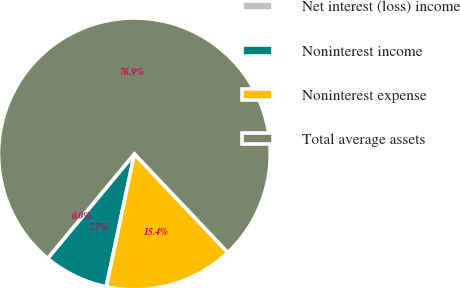Convert chart to OTSL. <chart><loc_0><loc_0><loc_500><loc_500><pie_chart><fcel>Net interest (loss) income<fcel>Noninterest income<fcel>Noninterest expense<fcel>Total average assets<nl><fcel>0.01%<fcel>7.7%<fcel>15.39%<fcel>76.9%<nl></chart> 